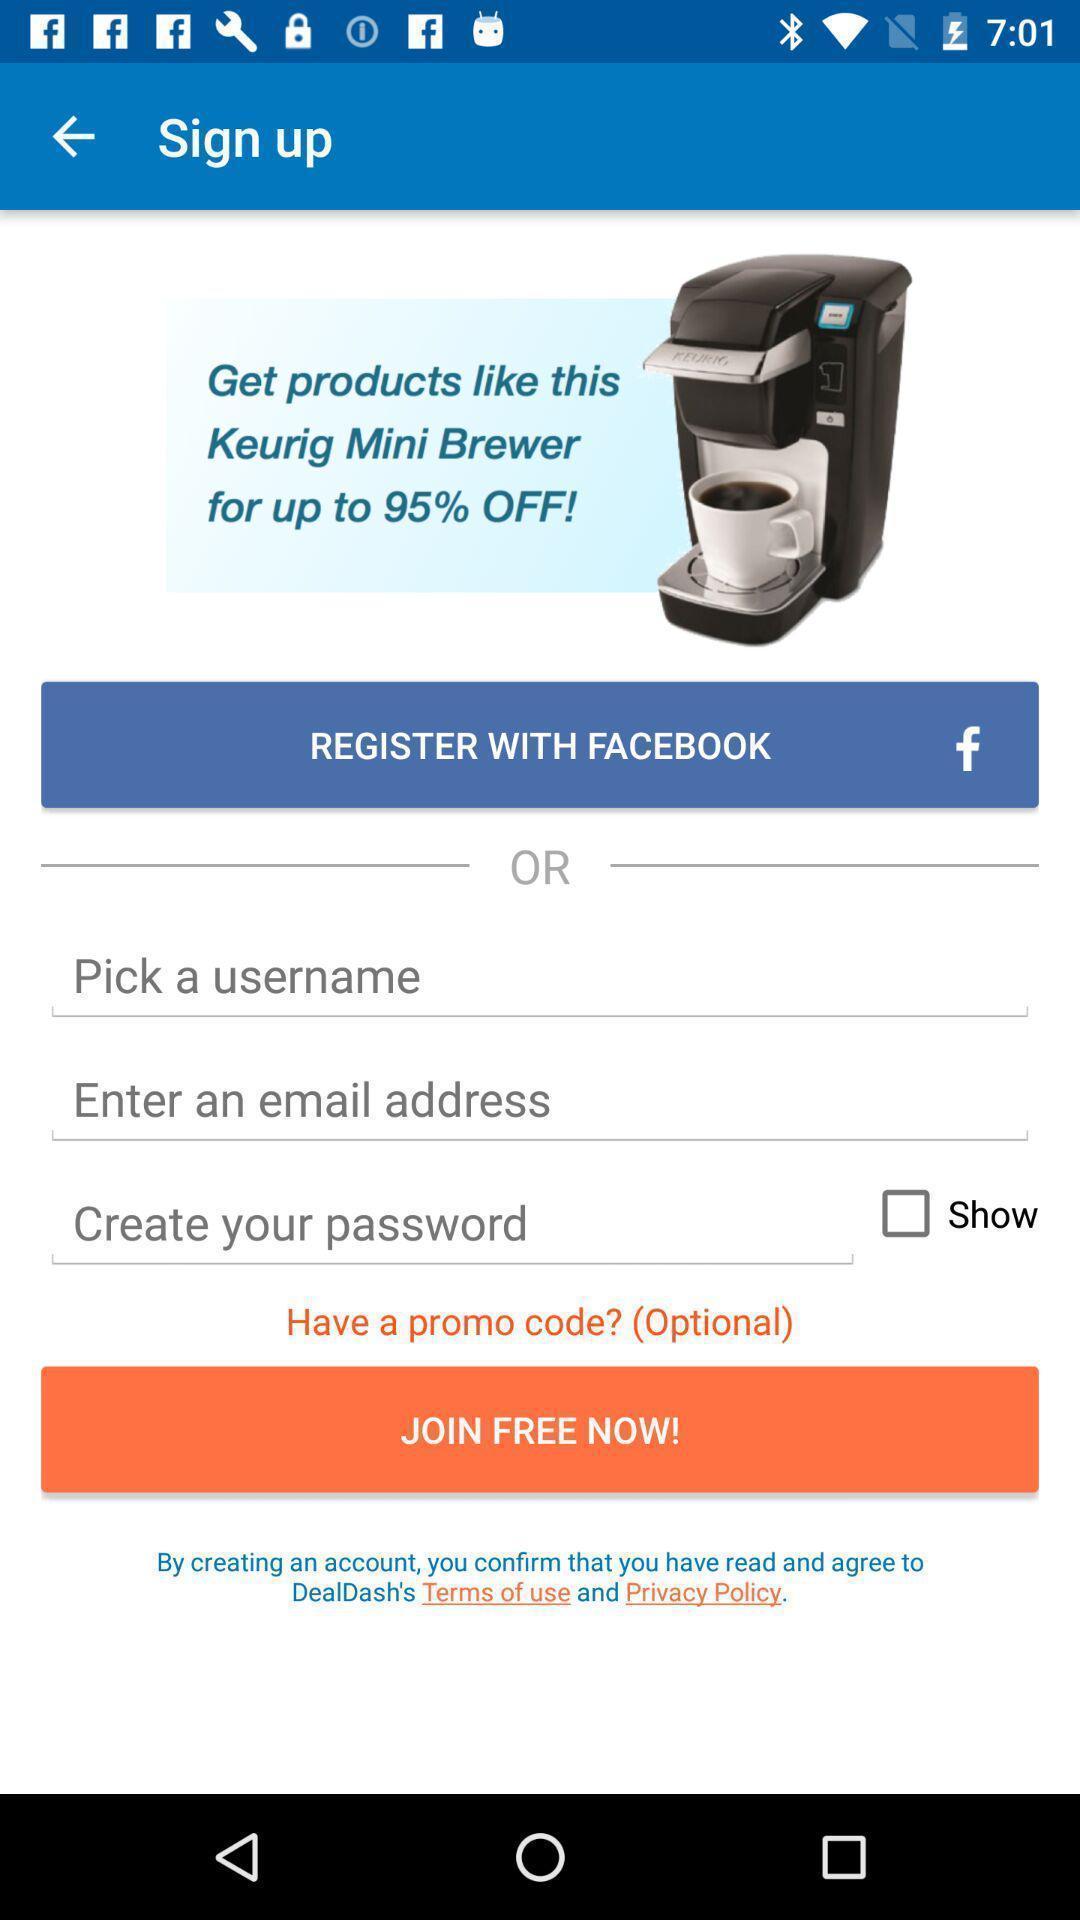Describe the key features of this screenshot. Signup page of a shopping app. 